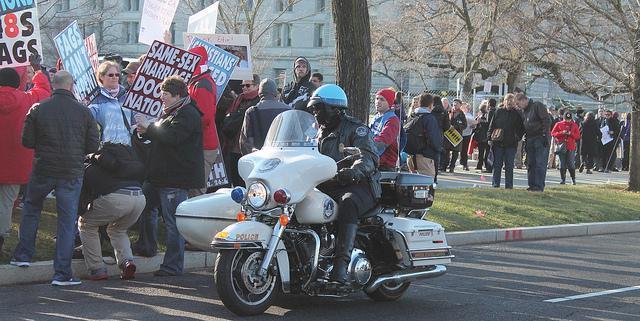How many men are on the bike?
Give a very brief answer. 1. How many people are there?
Give a very brief answer. 9. 